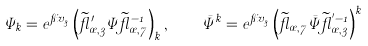Convert formula to latex. <formula><loc_0><loc_0><loc_500><loc_500>\Psi _ { k } = e ^ { \pi i v _ { 3 } } \left ( \widetilde { \gamma } ^ { \prime } _ { \sigma , 3 } \Psi \widetilde { \gamma } _ { \sigma , 7 } ^ { - 1 } \right ) _ { k } , \quad \bar { \Psi } ^ { k } = e ^ { \pi i v _ { 3 } } \left ( \widetilde { \gamma } _ { \sigma , 7 } \bar { \Psi } \widetilde { \gamma } _ { \sigma , 3 } ^ { ^ { \prime } - 1 } \right ) ^ { k }</formula> 